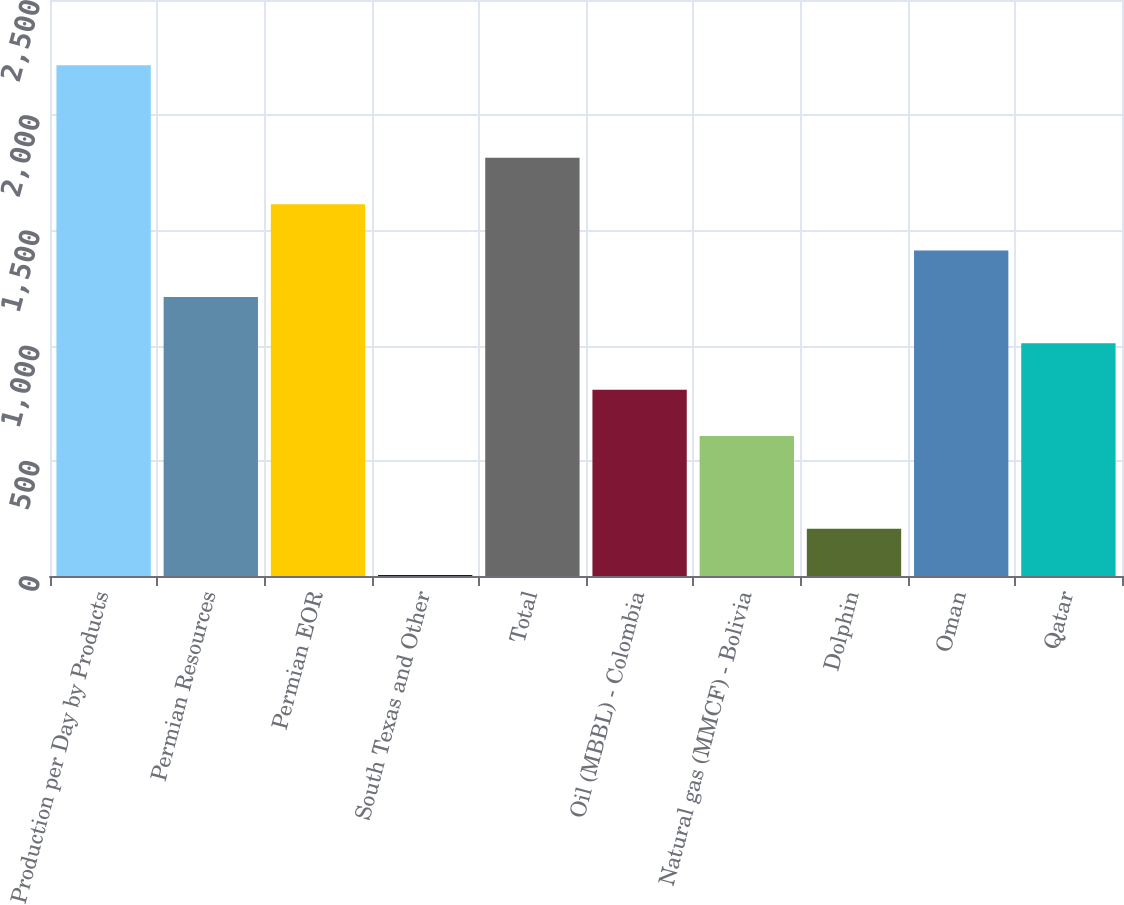Convert chart. <chart><loc_0><loc_0><loc_500><loc_500><bar_chart><fcel>Production per Day by Products<fcel>Permian Resources<fcel>Permian EOR<fcel>South Texas and Other<fcel>Total<fcel>Oil (MBBL) - Colombia<fcel>Natural gas (MMCF) - Bolivia<fcel>Dolphin<fcel>Oman<fcel>Qatar<nl><fcel>2217.2<fcel>1211.2<fcel>1613.6<fcel>4<fcel>1814.8<fcel>808.8<fcel>607.6<fcel>205.2<fcel>1412.4<fcel>1010<nl></chart> 